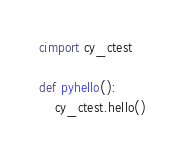Convert code to text. <code><loc_0><loc_0><loc_500><loc_500><_Cython_>cimport cy_ctest

def pyhello():
    cy_ctest.hello()
</code> 